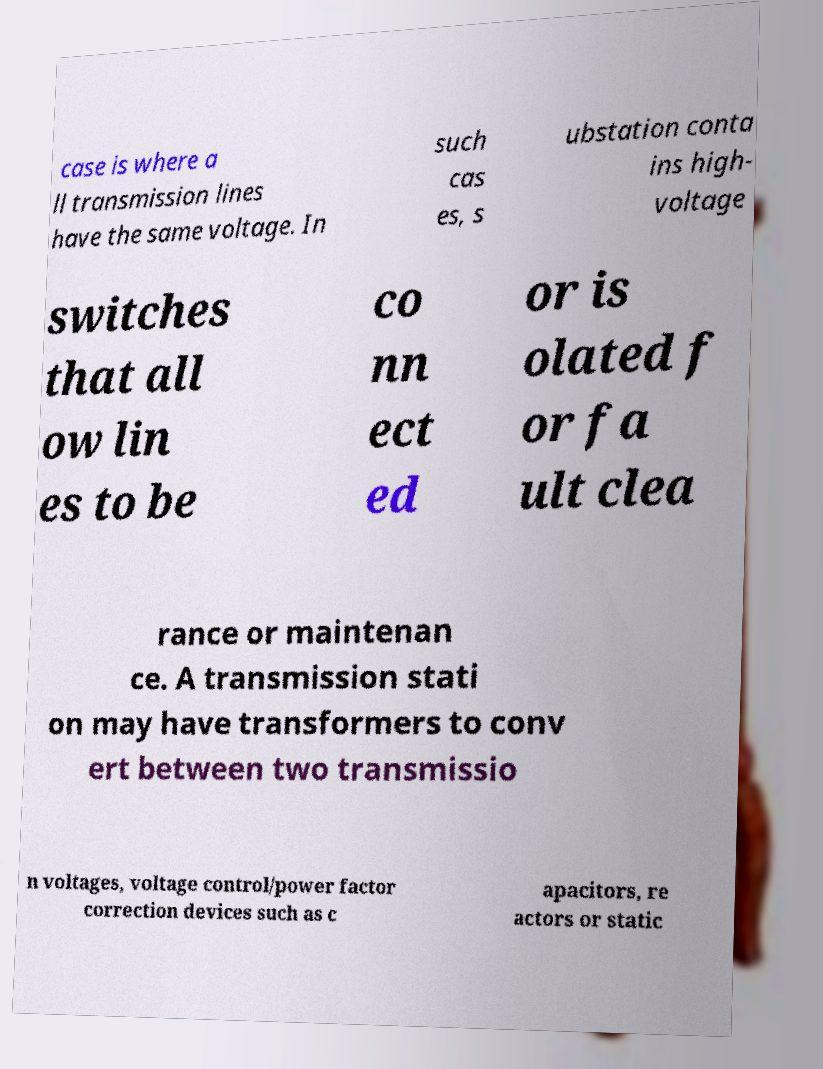Could you assist in decoding the text presented in this image and type it out clearly? case is where a ll transmission lines have the same voltage. In such cas es, s ubstation conta ins high- voltage switches that all ow lin es to be co nn ect ed or is olated f or fa ult clea rance or maintenan ce. A transmission stati on may have transformers to conv ert between two transmissio n voltages, voltage control/power factor correction devices such as c apacitors, re actors or static 